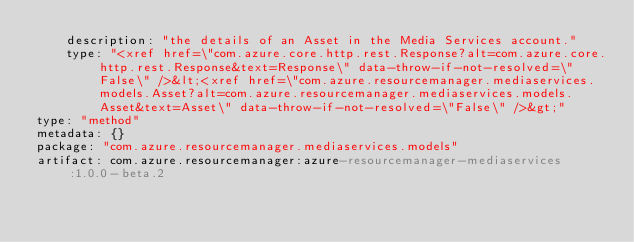Convert code to text. <code><loc_0><loc_0><loc_500><loc_500><_YAML_>    description: "the details of an Asset in the Media Services account."
    type: "<xref href=\"com.azure.core.http.rest.Response?alt=com.azure.core.http.rest.Response&text=Response\" data-throw-if-not-resolved=\"False\" />&lt;<xref href=\"com.azure.resourcemanager.mediaservices.models.Asset?alt=com.azure.resourcemanager.mediaservices.models.Asset&text=Asset\" data-throw-if-not-resolved=\"False\" />&gt;"
type: "method"
metadata: {}
package: "com.azure.resourcemanager.mediaservices.models"
artifact: com.azure.resourcemanager:azure-resourcemanager-mediaservices:1.0.0-beta.2
</code> 